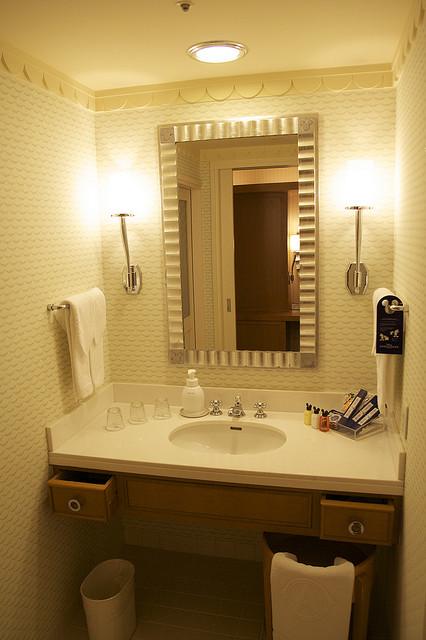How many lamps are on?
Quick response, please. 2. Is it dark in this room?
Keep it brief. No. Is there a trash can?
Keep it brief. Yes. 